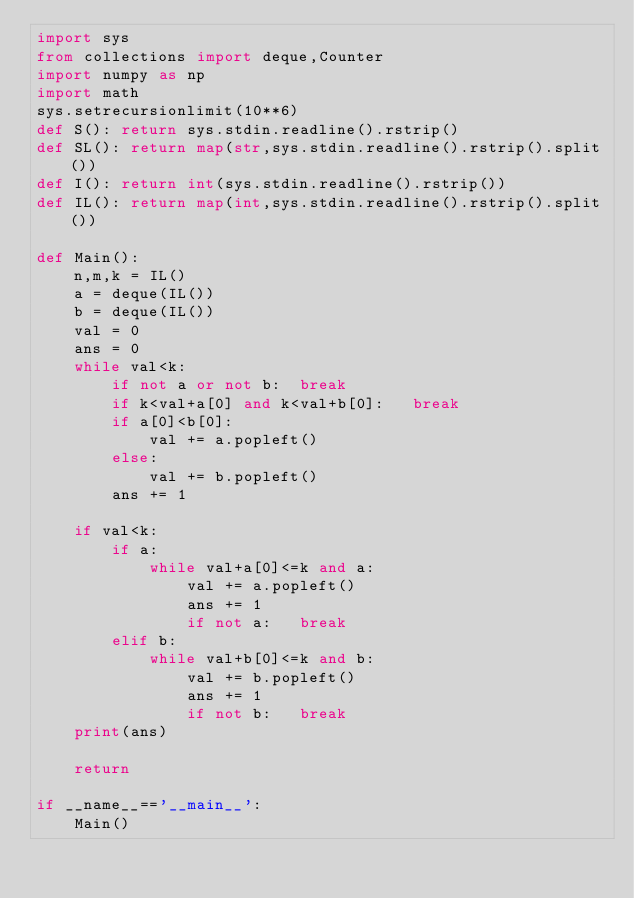Convert code to text. <code><loc_0><loc_0><loc_500><loc_500><_Python_>import sys
from collections import deque,Counter
import numpy as np
import math
sys.setrecursionlimit(10**6)
def S(): return sys.stdin.readline().rstrip()
def SL(): return map(str,sys.stdin.readline().rstrip().split())
def I(): return int(sys.stdin.readline().rstrip())
def IL(): return map(int,sys.stdin.readline().rstrip().split())

def Main():
    n,m,k = IL()
    a = deque(IL())
    b = deque(IL())
    val = 0
    ans = 0
    while val<k:
        if not a or not b:  break
        if k<val+a[0] and k<val+b[0]:   break
        if a[0]<b[0]:
            val += a.popleft()
        else:
            val += b.popleft()
        ans += 1
    
    if val<k:
        if a:
            while val+a[0]<=k and a:
                val += a.popleft()
                ans += 1
                if not a:   break
        elif b:
            while val+b[0]<=k and b:
                val += b.popleft()
                ans += 1
                if not b:   break
    print(ans)

    return

if __name__=='__main__':
    Main()</code> 